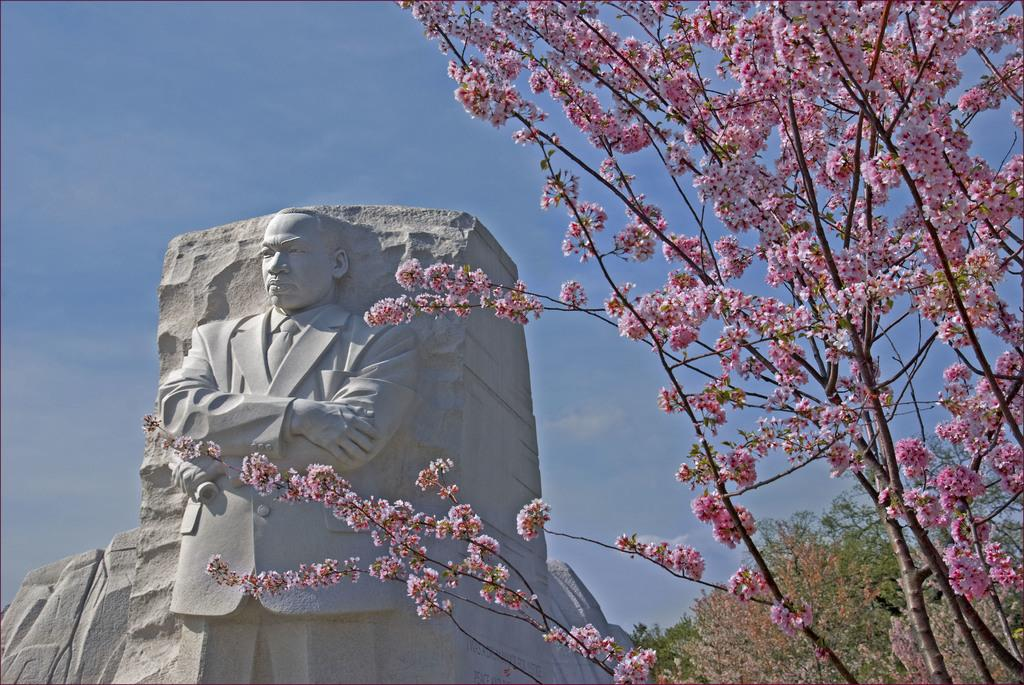What type of tree is on the right side of the image? There is a pink flower tree on the right side of the image. What can be seen at the back of the image? There is a sculpture at the back of the image. What type of vegetation is on the right side of the image besides the pink flower tree? There are trees on the right side of the image. What is visible at the top of the image? The sky is visible at the top of the image. How many stars can be seen in the image? There are no stars visible in the image; only the pink flower tree, sculpture, trees, and sky are present. Is there a swing hanging from the pink flower tree in the image? No, there is no swing present in the image. 